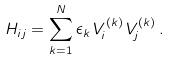<formula> <loc_0><loc_0><loc_500><loc_500>H _ { i j } = \sum _ { k = 1 } ^ { N } \epsilon _ { k } \, V _ { i } ^ { ( k ) } \, V _ { j } ^ { ( k ) } \, .</formula> 